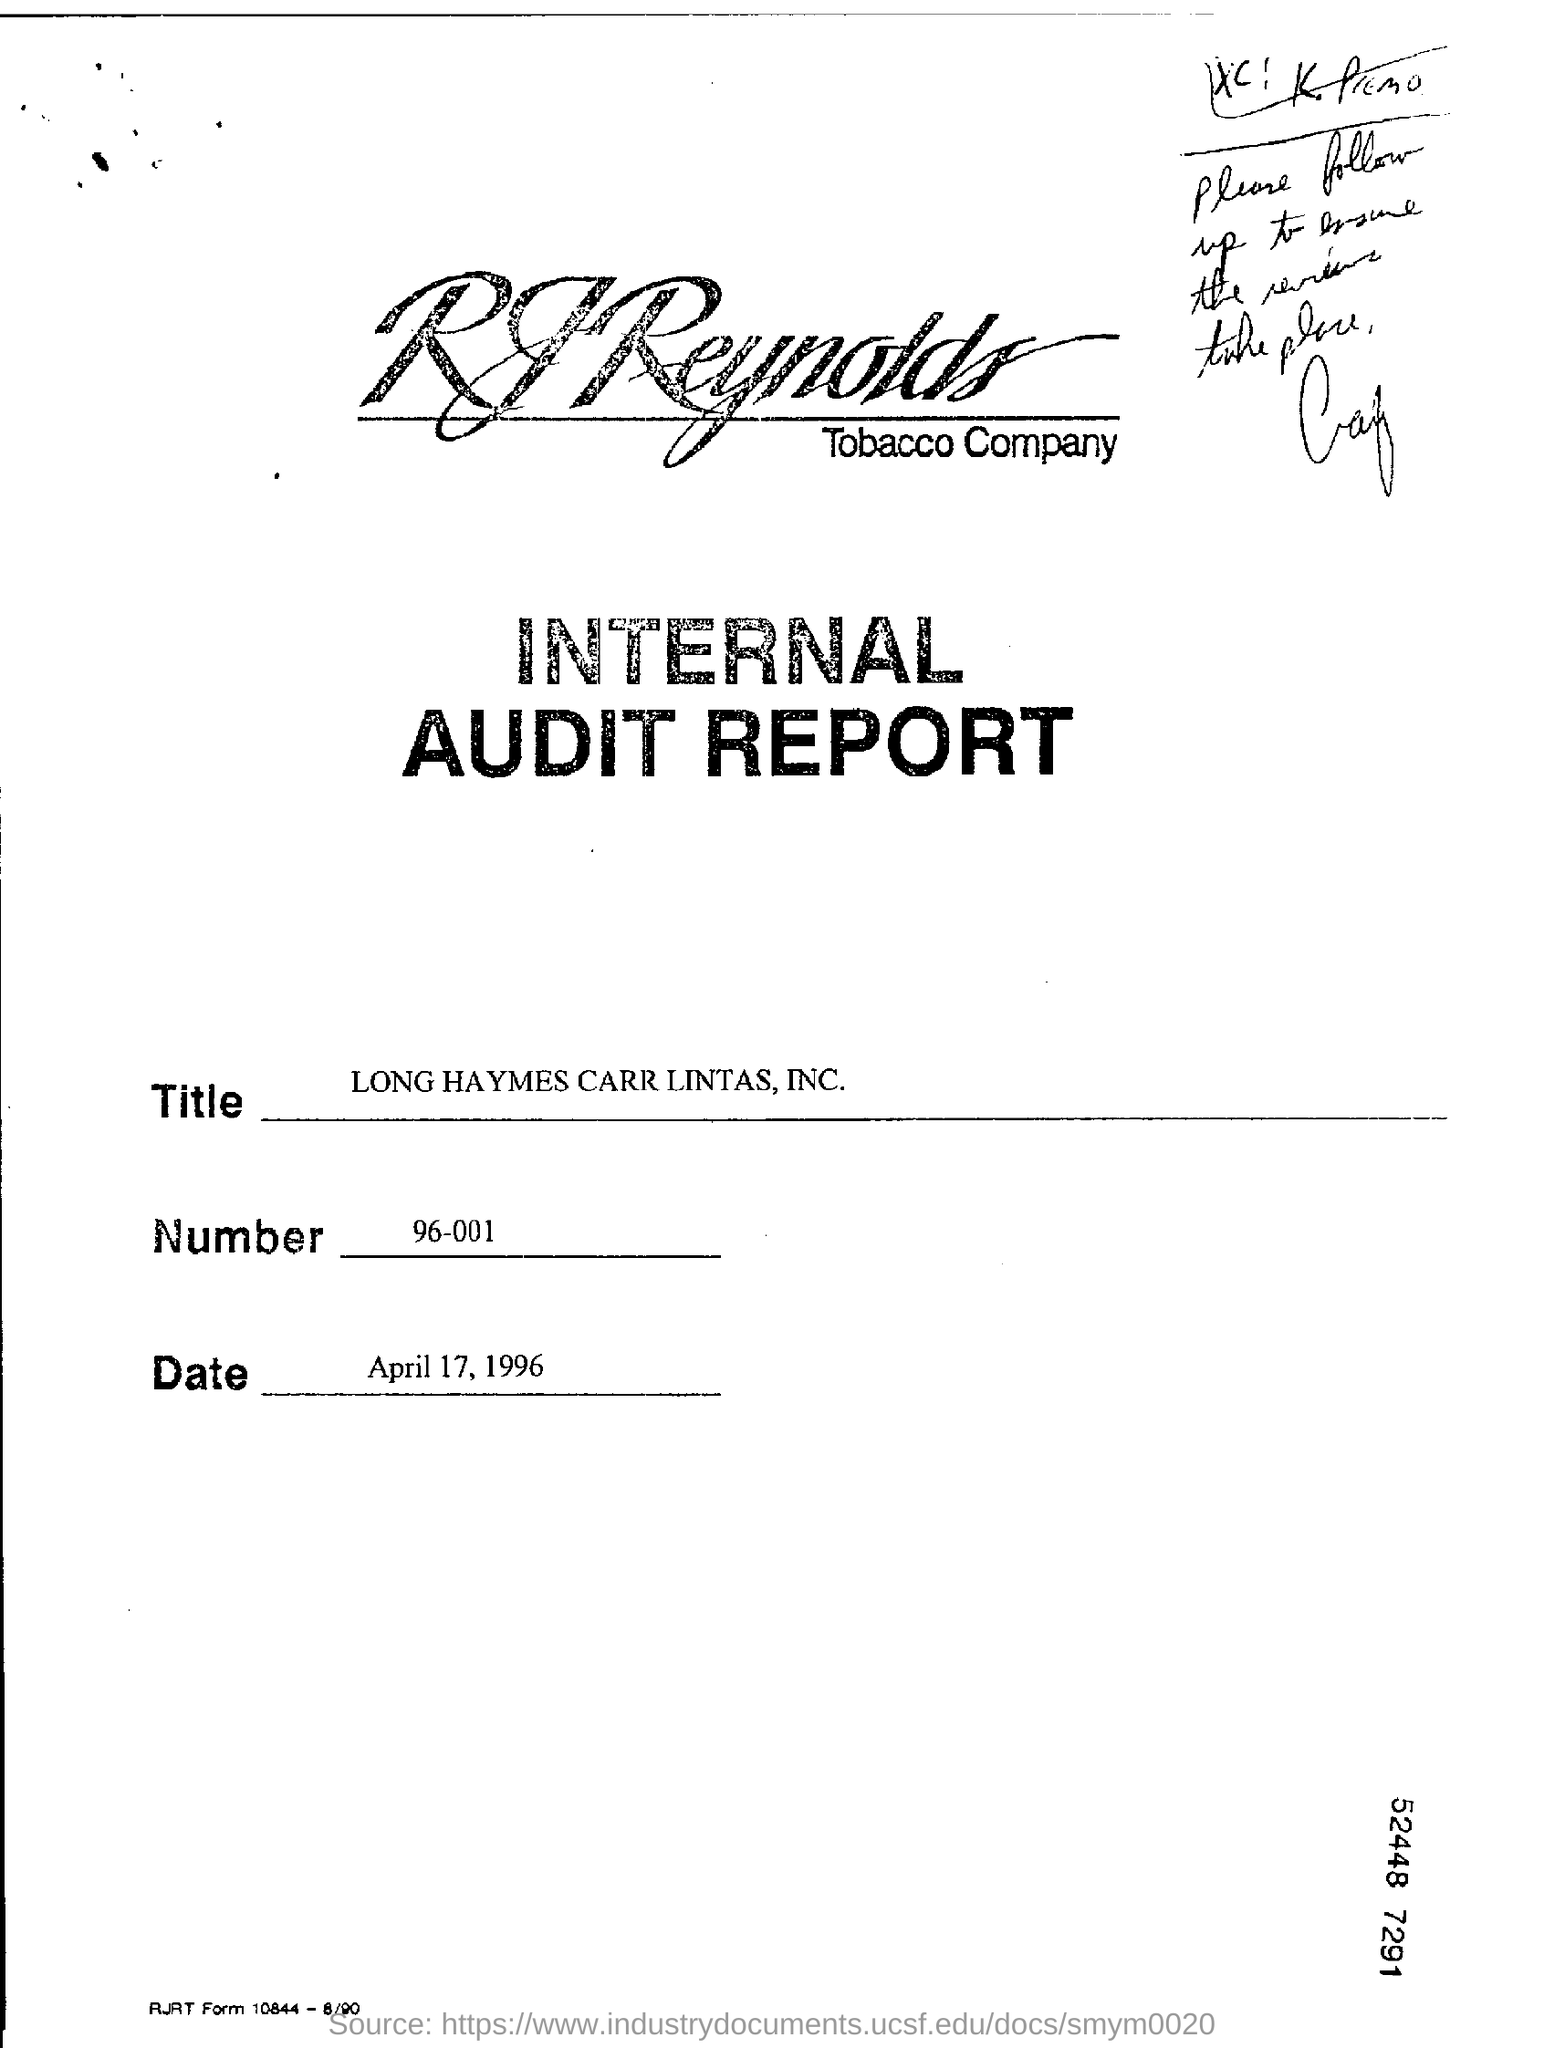Give some essential details in this illustration. The date mentioned in this document is April 17, 1996. The audit report is for RJ Reynolds Tobacco Company. The number mentioned in the document is 96-001. The title mentioned in this document is "LONG HAYMES CARR LINTAS, INC." 